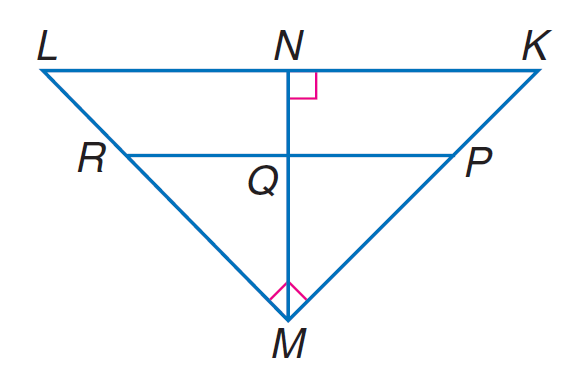Answer the mathemtical geometry problem and directly provide the correct option letter.
Question: If P R \parallel K L, K N = 9, L N = 16, P M = 2 K P, find K M.
Choices: A: 11 B: 15 C: 16.25 D: 17 B 